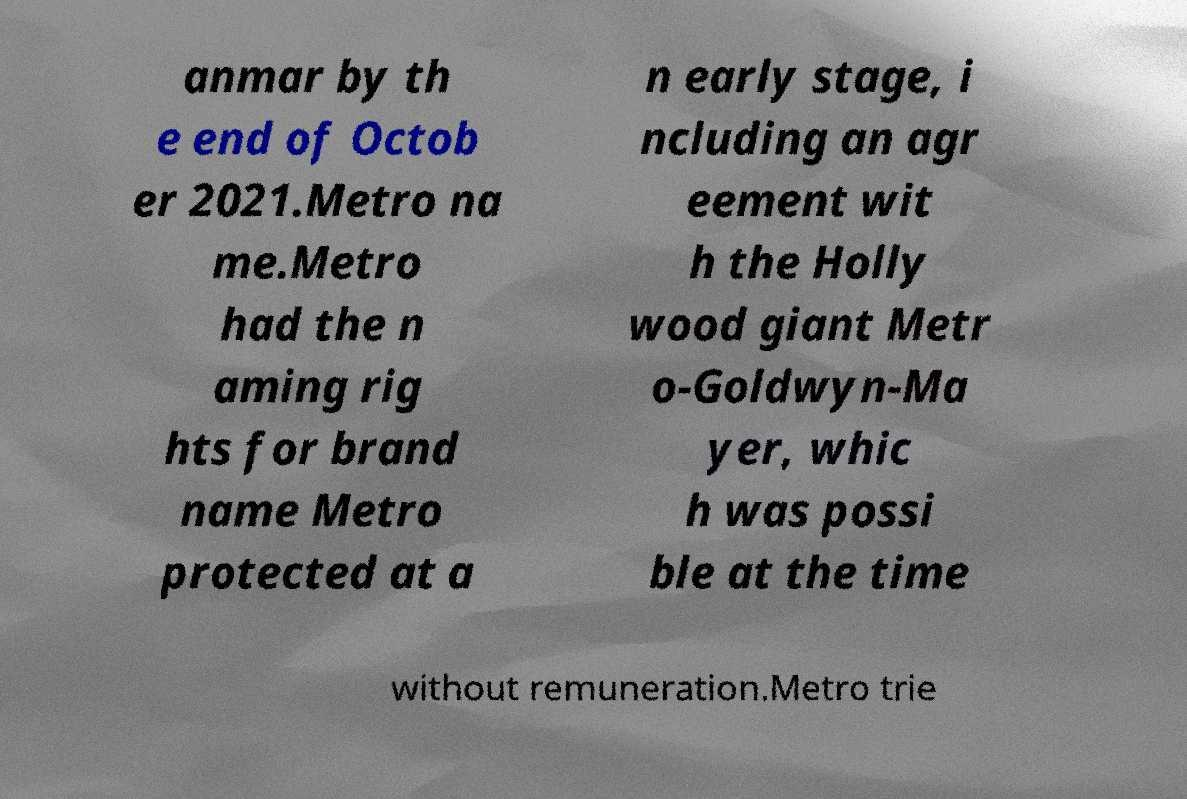I need the written content from this picture converted into text. Can you do that? anmar by th e end of Octob er 2021.Metro na me.Metro had the n aming rig hts for brand name Metro protected at a n early stage, i ncluding an agr eement wit h the Holly wood giant Metr o-Goldwyn-Ma yer, whic h was possi ble at the time without remuneration.Metro trie 